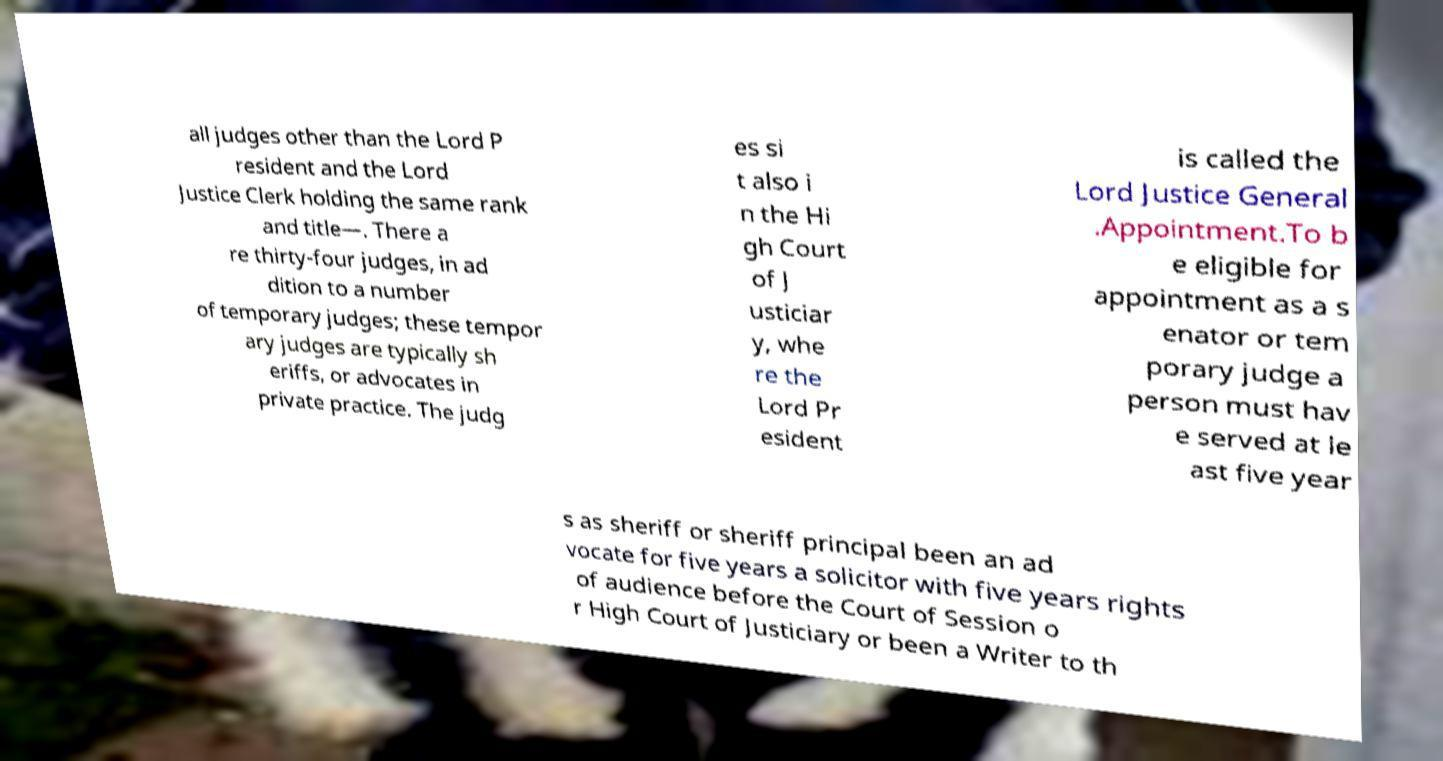What messages or text are displayed in this image? I need them in a readable, typed format. all judges other than the Lord P resident and the Lord Justice Clerk holding the same rank and title—. There a re thirty-four judges, in ad dition to a number of temporary judges; these tempor ary judges are typically sh eriffs, or advocates in private practice. The judg es si t also i n the Hi gh Court of J usticiar y, whe re the Lord Pr esident is called the Lord Justice General .Appointment.To b e eligible for appointment as a s enator or tem porary judge a person must hav e served at le ast five year s as sheriff or sheriff principal been an ad vocate for five years a solicitor with five years rights of audience before the Court of Session o r High Court of Justiciary or been a Writer to th 